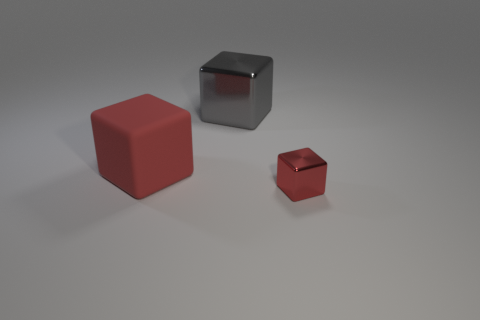What materials do the cubes in the image seem to be made of? The cubes appear to have different finishes: The large one on the left has a matte surface, possibly resembling a plastic or painted wood, while the center cube has a reflective surface akin to polished metal. 